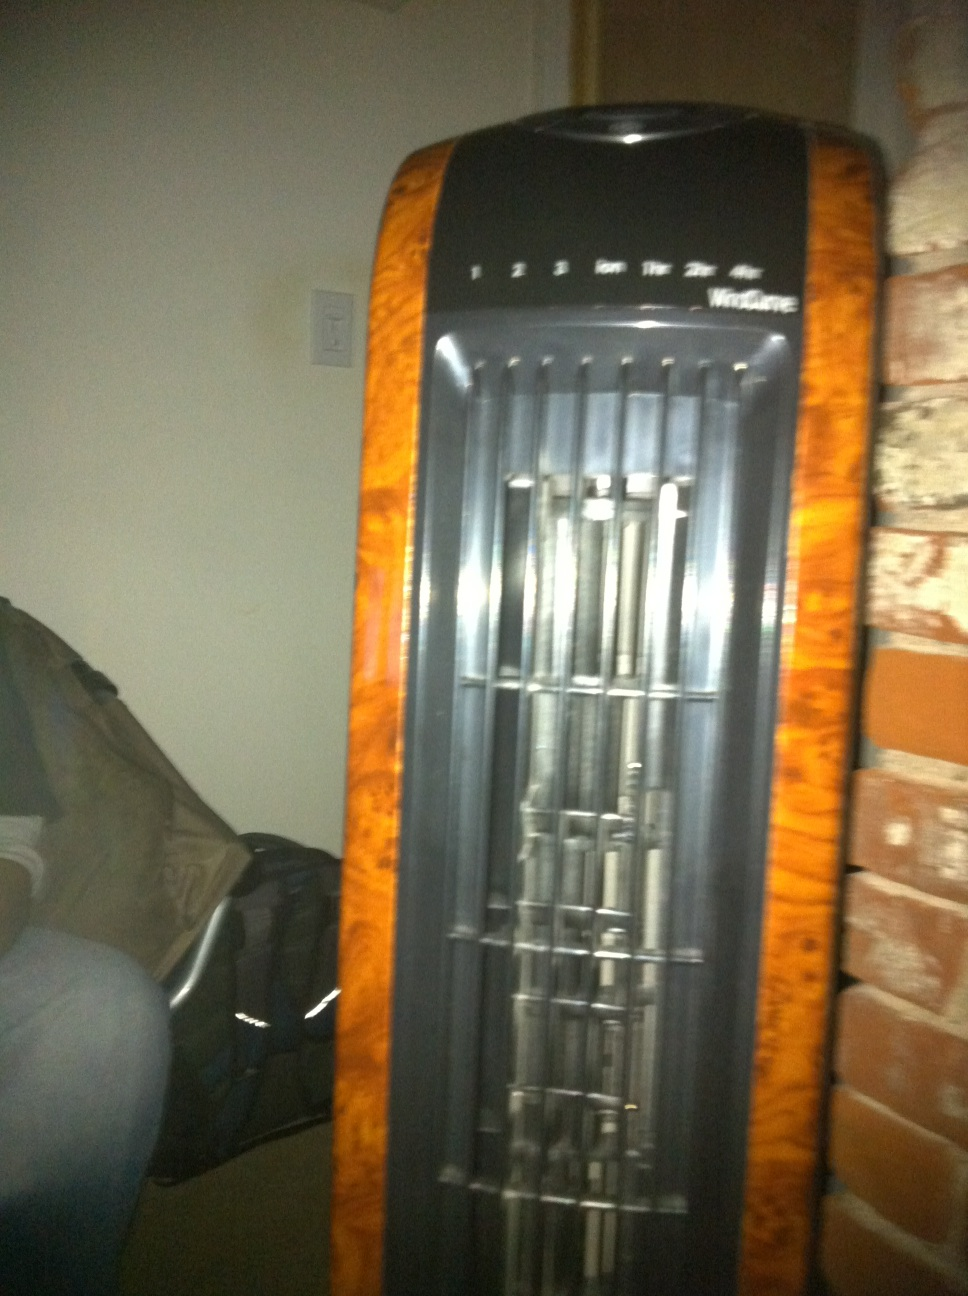What scenarios could this fan be in? Scenario 1: This fan is running quietly in the corner of a cozy bedroom, providing a gentle breeze as someone reads a book on their bed.
Scenario 2: The fan is placed in a living room during a family movie night, helping to keep the room cool and comfortable as everyone enjoys a summer blockbuster film. 